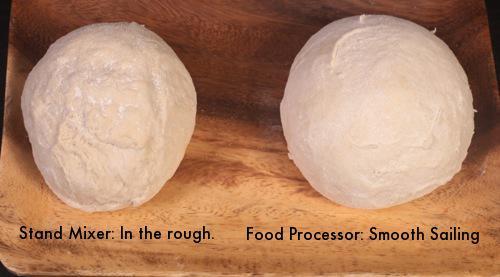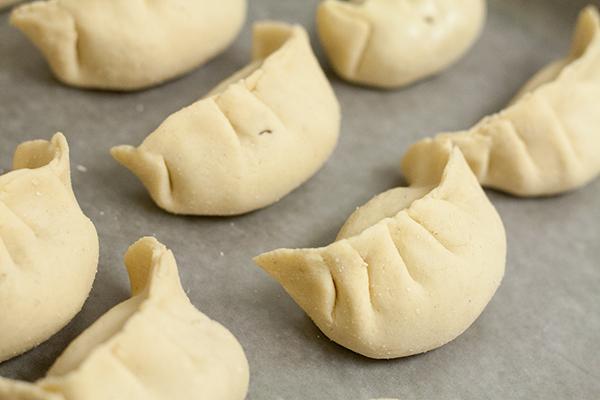The first image is the image on the left, the second image is the image on the right. Assess this claim about the two images: "A person has their hands in the dough in one picture but not the other.". Correct or not? Answer yes or no. No. 